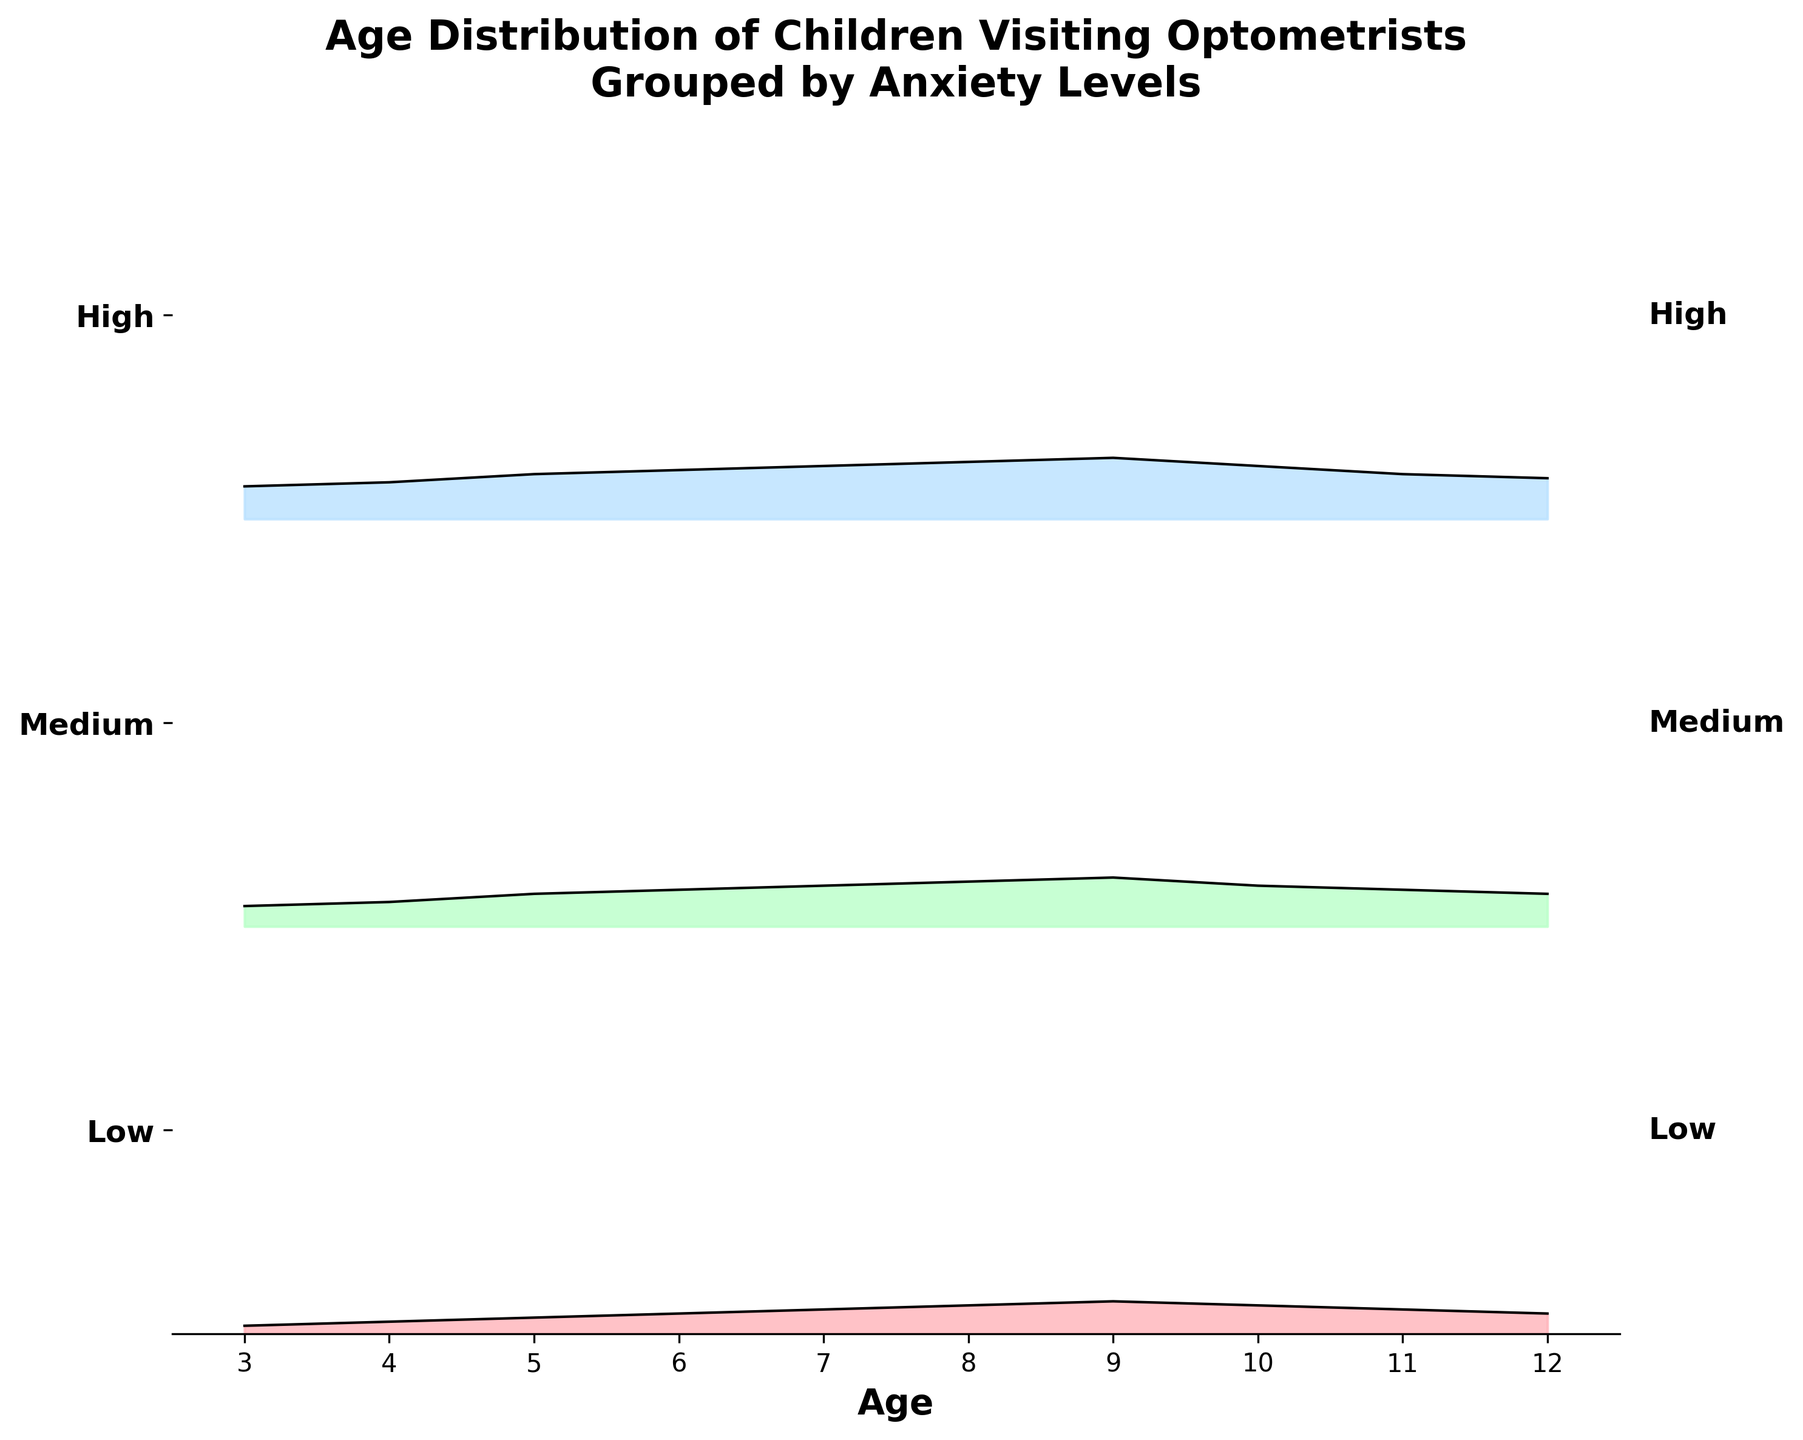What is the title of the plot? The title is found at the top of the figure and summarizes what the plot is about.
Answer: Age Distribution of Children Visiting Optometrists Grouped by Anxiety Levels Which anxiety level has the highest density for 9-year-olds? Locate the age 9 on the x-axis, then follow up vertically to see which density line is highest at that age. The highest density line appears in the ‘High’ anxiety level.
Answer: High How does the density change from age 3 to age 12 for the 'Medium' anxiety level? Trace the 'Medium' anxiety level line across the ages from 3 to 12 on the x-axis. It starts at 0.05 at age 3, increases to a peak of 0.12 at age 9, and then decreases again toward 0.08 at age 12.
Answer: Increases, peaks at 9, then decreases What age group has the lowest density across all anxiety levels? Compare the density values for each age across all three anxiety levels. Age 3 has the lowest density at all levels compared to other ages.
Answer: Age 3 Between what ages do the densities for the 'Low' anxiety level increase the most? Look at the 'Low' anxiety level line and note the difference in densities between ages. The steepest increase occurs between ages 3 to 9.
Answer: Ages 3 to 9 How does the density at age 10 for the 'High' anxiety level compare to the same age for the 'Low' anxiety level? Identify the density values for 'High' and 'Low' anxiety levels at age 10. For 'High,' it is 0.13 and for 'Low,' it is 0.07, meaning the 'High' anxiety level is almost twice as dense as the 'Low' at this age.
Answer: Higher for the 'High' anxiety level What can be concluded about the trend of anxiety levels as children age? Examining all three anxiety levels from age 3 to 12, there is a general increase in density of children with *Medium* and *High* anxiety levels until around age 9, and a slight decrease after that. For *Low* anxiety level, density increases more steadily until age 9 and then decreases more sharply after that.
Answer: Anxiety levels generally increase until age 9 then decrease At what age do 'Medium' and 'High' anxiety levels have the same density? Look for the point where the lines for 'Medium' and 'High' anxiety levels intersect. The lines intersect at age 11.
Answer: Age 11 Is the density trend for the 'Low' anxiety level consistent over the ages? Observe the 'Low' anxiety level line across the x-axis. The trend shows a more steady increase until age 9 and then a decrease, indicating it is not consistent.
Answer: No 